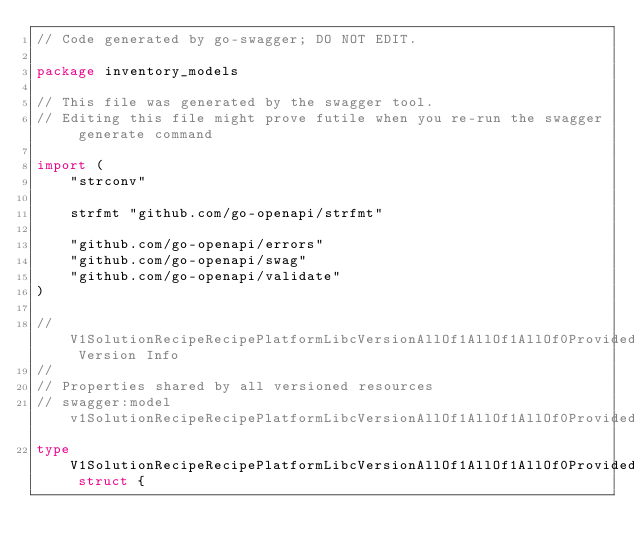<code> <loc_0><loc_0><loc_500><loc_500><_Go_>// Code generated by go-swagger; DO NOT EDIT.

package inventory_models

// This file was generated by the swagger tool.
// Editing this file might prove futile when you re-run the swagger generate command

import (
	"strconv"

	strfmt "github.com/go-openapi/strfmt"

	"github.com/go-openapi/errors"
	"github.com/go-openapi/swag"
	"github.com/go-openapi/validate"
)

// V1SolutionRecipeRecipePlatformLibcVersionAllOf1AllOf1AllOf0ProvidedFeaturesItemsAllOf1 Version Info
//
// Properties shared by all versioned resources
// swagger:model v1SolutionRecipeRecipePlatformLibcVersionAllOf1AllOf1AllOf0ProvidedFeaturesItemsAllOf1
type V1SolutionRecipeRecipePlatformLibcVersionAllOf1AllOf1AllOf0ProvidedFeaturesItemsAllOf1 struct {
</code> 